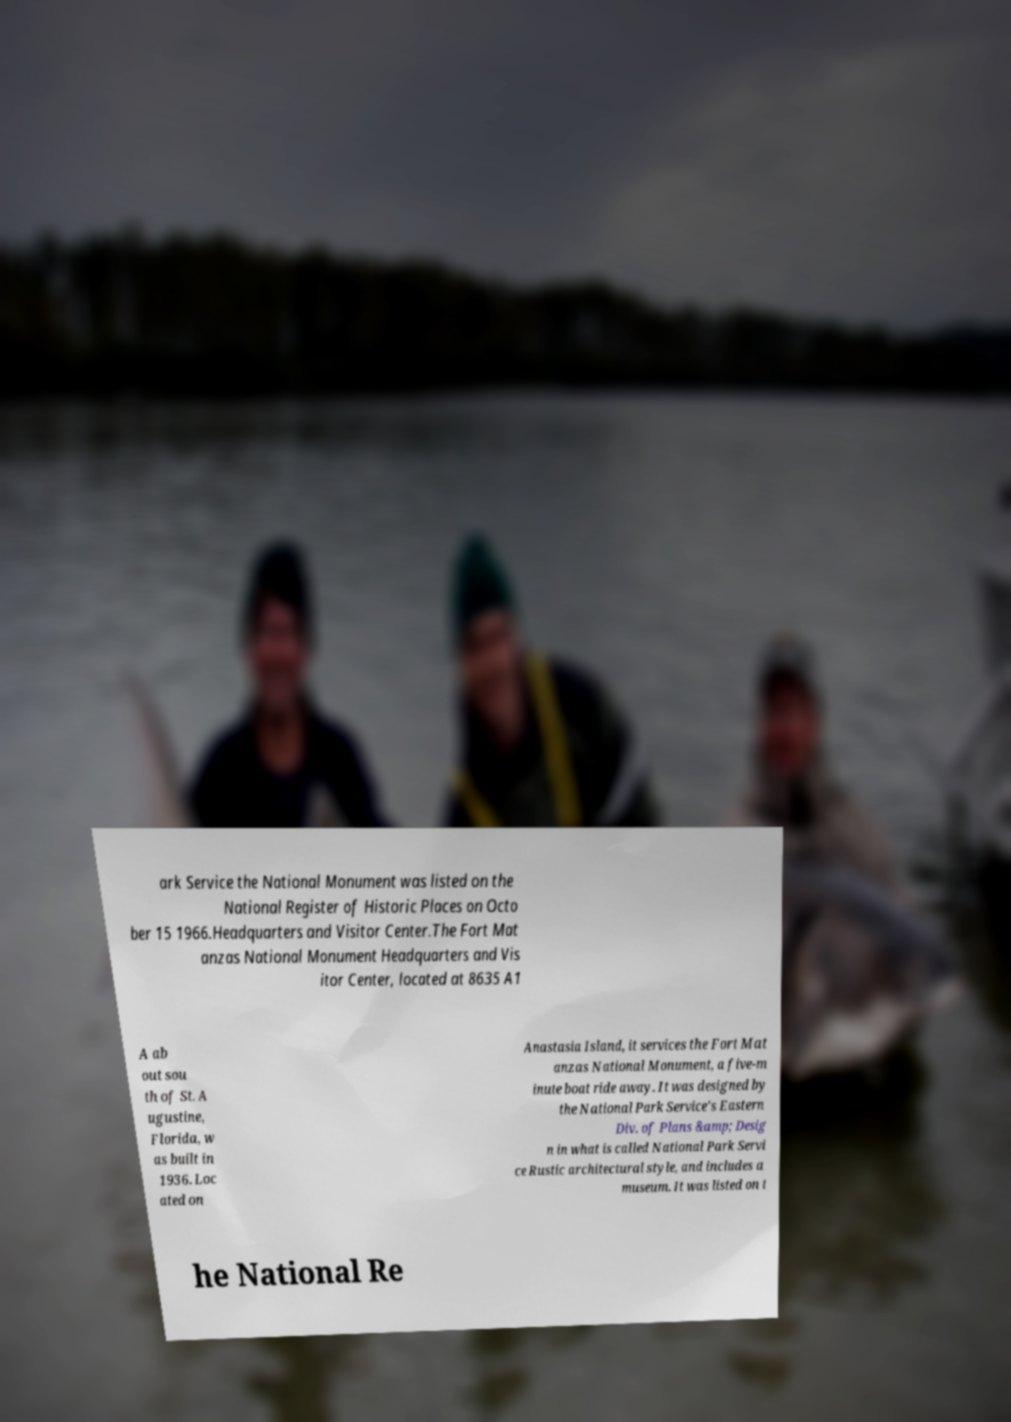What messages or text are displayed in this image? I need them in a readable, typed format. ark Service the National Monument was listed on the National Register of Historic Places on Octo ber 15 1966.Headquarters and Visitor Center.The Fort Mat anzas National Monument Headquarters and Vis itor Center, located at 8635 A1 A ab out sou th of St. A ugustine, Florida, w as built in 1936. Loc ated on Anastasia Island, it services the Fort Mat anzas National Monument, a five-m inute boat ride away. It was designed by the National Park Service's Eastern Div. of Plans &amp; Desig n in what is called National Park Servi ce Rustic architectural style, and includes a museum. It was listed on t he National Re 